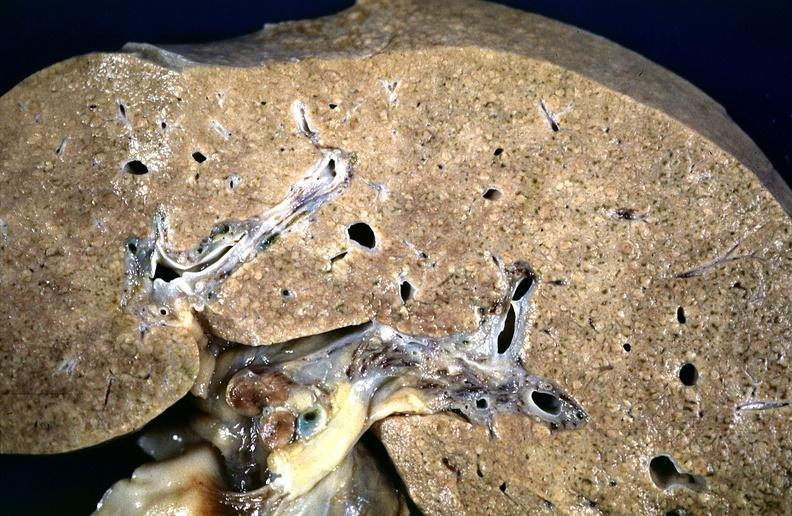what does this image show?
Answer the question using a single word or phrase. Cirrhosis 